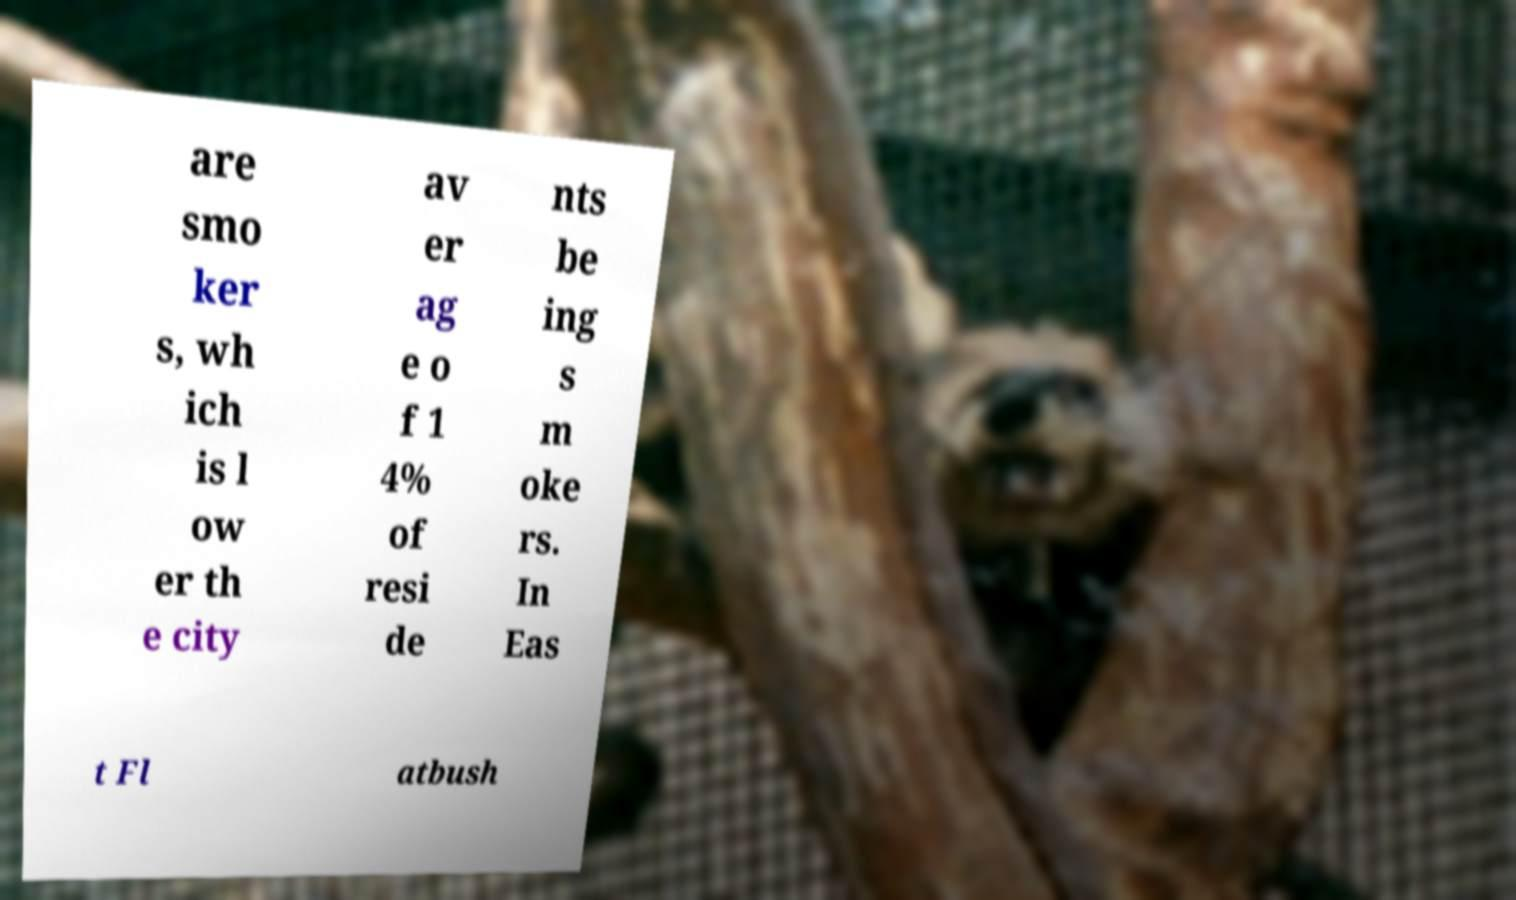Please identify and transcribe the text found in this image. are smo ker s, wh ich is l ow er th e city av er ag e o f 1 4% of resi de nts be ing s m oke rs. In Eas t Fl atbush 